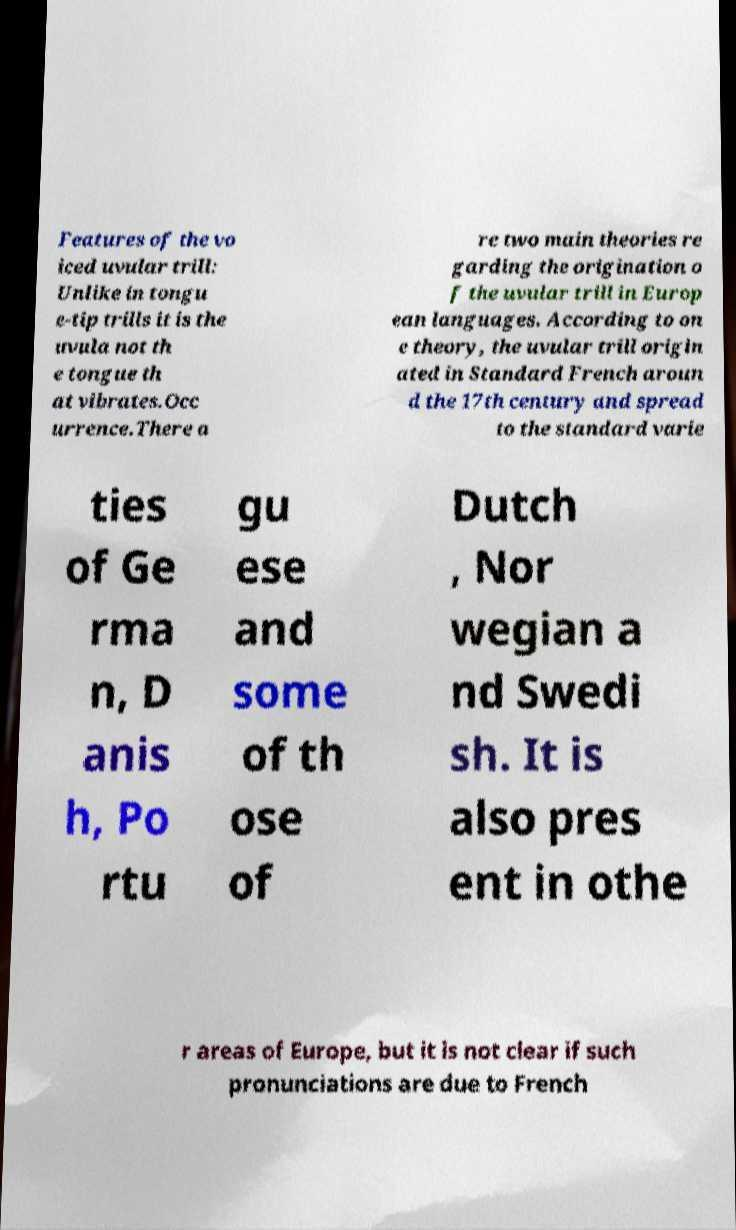What messages or text are displayed in this image? I need them in a readable, typed format. Features of the vo iced uvular trill: Unlike in tongu e-tip trills it is the uvula not th e tongue th at vibrates.Occ urrence.There a re two main theories re garding the origination o f the uvular trill in Europ ean languages. According to on e theory, the uvular trill origin ated in Standard French aroun d the 17th century and spread to the standard varie ties of Ge rma n, D anis h, Po rtu gu ese and some of th ose of Dutch , Nor wegian a nd Swedi sh. It is also pres ent in othe r areas of Europe, but it is not clear if such pronunciations are due to French 